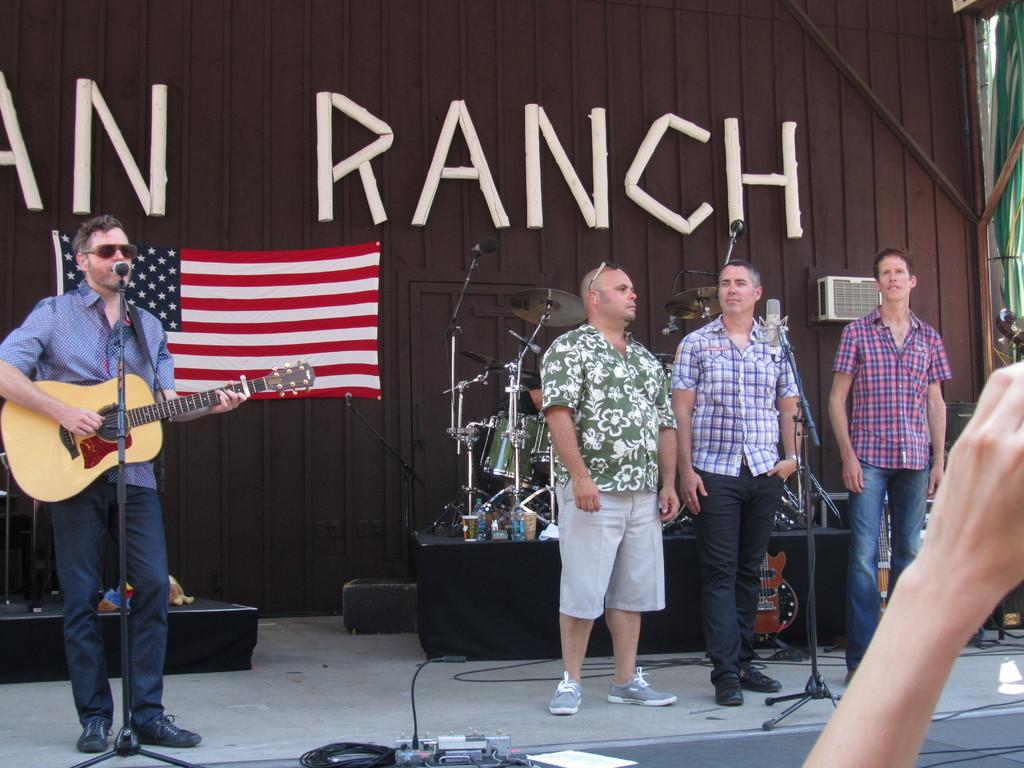What can be seen in the image that represents a symbol or country? There is a flag in the image. What is the man in the image holding? The man is holding a guitar in the image. How many people are standing in the image? There are three people standing in the image. What musical instrument can be seen in the background of the image? There are musical drums in the background of the image. What type of surprise can be seen on the man's face in the image? There is no indication of a surprise or any specific facial expression on the man's face in the image. What sense is being stimulated by the musical instruments in the image? The question is not relevant to the image, as it does not mention any sensory experiences or stimuli. 